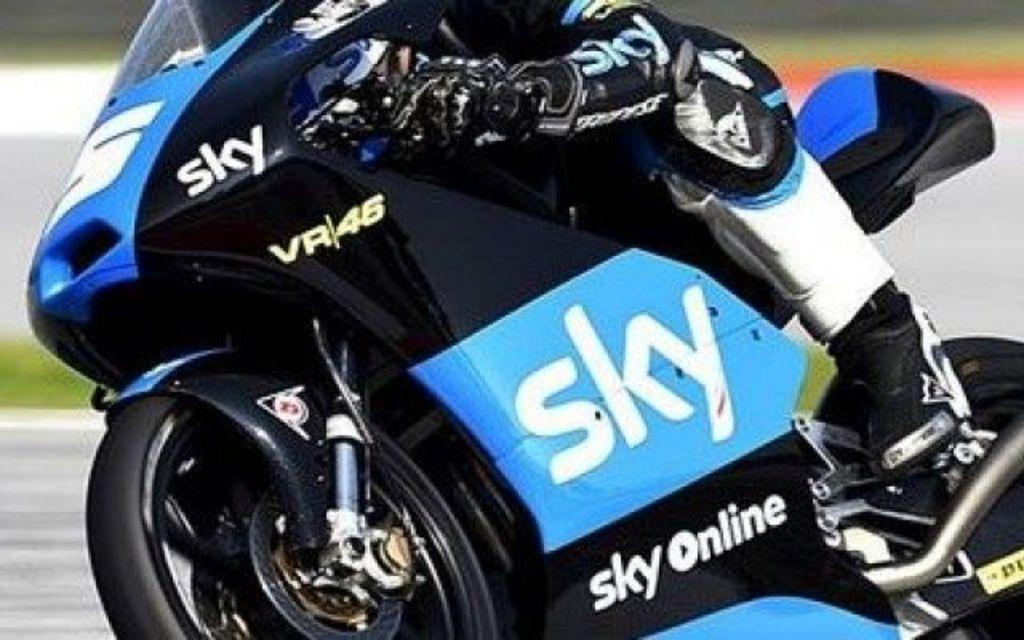What is the main subject of the image? The main subject of the image is a person riding a sports bike. What can be seen on the sports bike? There is text written on the sports bike. What type of pail is being used to exercise the person's muscles in the image? There is no pail or muscle exercise visible in the image. What type of payment is being made by the person riding the sports bike in the image? There is no payment being made in the image; it only shows a person riding a sports bike with text on it. 